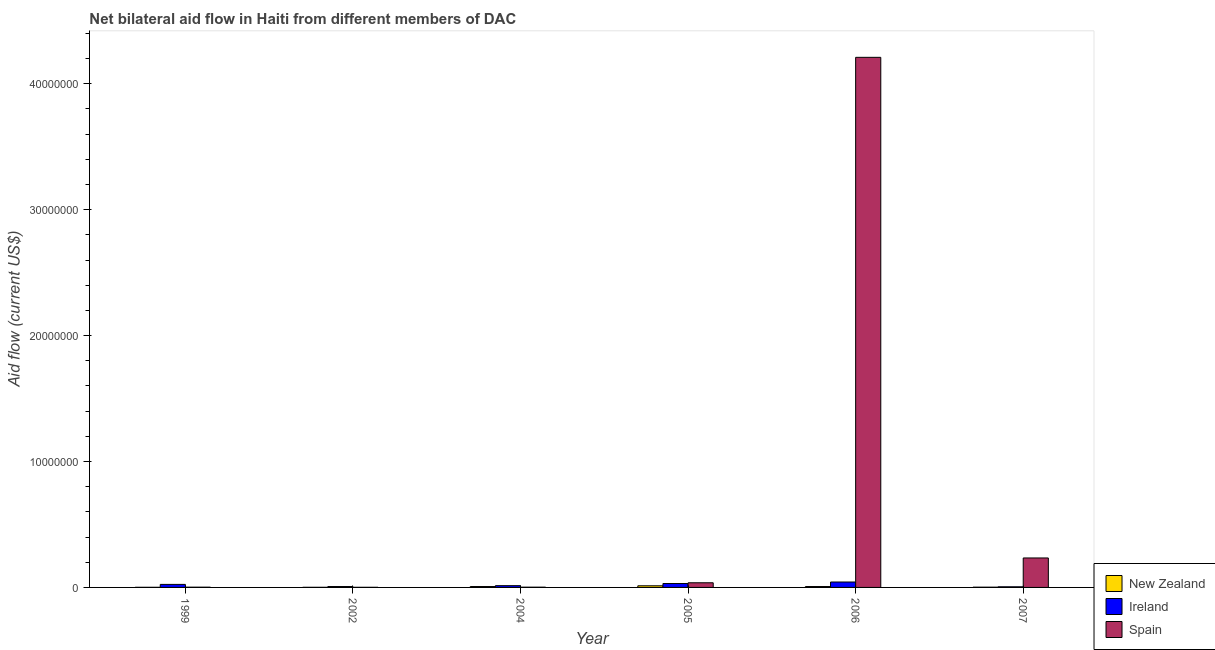How many groups of bars are there?
Provide a short and direct response. 6. In how many cases, is the number of bars for a given year not equal to the number of legend labels?
Provide a succinct answer. 0. What is the amount of aid provided by ireland in 2004?
Your answer should be compact. 1.40e+05. Across all years, what is the maximum amount of aid provided by spain?
Make the answer very short. 4.21e+07. Across all years, what is the minimum amount of aid provided by new zealand?
Provide a short and direct response. 10000. In which year was the amount of aid provided by spain minimum?
Your answer should be very brief. 2002. What is the total amount of aid provided by new zealand in the graph?
Keep it short and to the point. 3.10e+05. What is the difference between the amount of aid provided by new zealand in 2004 and that in 2007?
Your answer should be very brief. 5.00e+04. What is the difference between the amount of aid provided by new zealand in 2007 and the amount of aid provided by ireland in 2002?
Give a very brief answer. 10000. What is the average amount of aid provided by ireland per year?
Make the answer very short. 2.07e+05. In the year 2002, what is the difference between the amount of aid provided by spain and amount of aid provided by new zealand?
Keep it short and to the point. 0. In how many years, is the amount of aid provided by spain greater than 30000000 US$?
Offer a very short reply. 1. What is the ratio of the amount of aid provided by new zealand in 1999 to that in 2007?
Offer a terse response. 0.5. Is the amount of aid provided by ireland in 2002 less than that in 2006?
Ensure brevity in your answer.  Yes. Is the difference between the amount of aid provided by new zealand in 2004 and 2007 greater than the difference between the amount of aid provided by ireland in 2004 and 2007?
Keep it short and to the point. No. What is the difference between the highest and the lowest amount of aid provided by spain?
Your answer should be very brief. 4.21e+07. In how many years, is the amount of aid provided by spain greater than the average amount of aid provided by spain taken over all years?
Give a very brief answer. 1. Is the sum of the amount of aid provided by ireland in 1999 and 2004 greater than the maximum amount of aid provided by spain across all years?
Keep it short and to the point. No. What does the 2nd bar from the left in 2005 represents?
Make the answer very short. Ireland. What does the 2nd bar from the right in 2004 represents?
Your answer should be compact. Ireland. Is it the case that in every year, the sum of the amount of aid provided by new zealand and amount of aid provided by ireland is greater than the amount of aid provided by spain?
Offer a terse response. No. How many bars are there?
Make the answer very short. 18. Are all the bars in the graph horizontal?
Offer a terse response. No. How many years are there in the graph?
Your answer should be compact. 6. What is the difference between two consecutive major ticks on the Y-axis?
Ensure brevity in your answer.  1.00e+07. Does the graph contain any zero values?
Keep it short and to the point. No. Does the graph contain grids?
Your answer should be compact. No. How are the legend labels stacked?
Your answer should be compact. Vertical. What is the title of the graph?
Ensure brevity in your answer.  Net bilateral aid flow in Haiti from different members of DAC. What is the label or title of the Y-axis?
Provide a short and direct response. Aid flow (current US$). What is the Aid flow (current US$) of New Zealand in 1999?
Make the answer very short. 10000. What is the Aid flow (current US$) of Spain in 1999?
Your response must be concise. 2.00e+04. What is the Aid flow (current US$) of New Zealand in 2002?
Keep it short and to the point. 10000. What is the Aid flow (current US$) in Ireland in 2002?
Offer a very short reply. 7.00e+04. What is the Aid flow (current US$) in Spain in 2002?
Give a very brief answer. 10000. What is the Aid flow (current US$) of New Zealand in 2004?
Offer a terse response. 7.00e+04. What is the Aid flow (current US$) in Ireland in 2004?
Ensure brevity in your answer.  1.40e+05. What is the Aid flow (current US$) of Spain in 2004?
Your answer should be compact. 2.00e+04. What is the Aid flow (current US$) of Spain in 2005?
Keep it short and to the point. 3.70e+05. What is the Aid flow (current US$) in New Zealand in 2006?
Ensure brevity in your answer.  7.00e+04. What is the Aid flow (current US$) of Ireland in 2006?
Your answer should be compact. 4.30e+05. What is the Aid flow (current US$) of Spain in 2006?
Provide a succinct answer. 4.21e+07. What is the Aid flow (current US$) in Ireland in 2007?
Give a very brief answer. 5.00e+04. What is the Aid flow (current US$) of Spain in 2007?
Keep it short and to the point. 2.34e+06. Across all years, what is the maximum Aid flow (current US$) in Spain?
Provide a succinct answer. 4.21e+07. Across all years, what is the minimum Aid flow (current US$) in Ireland?
Keep it short and to the point. 5.00e+04. What is the total Aid flow (current US$) of Ireland in the graph?
Ensure brevity in your answer.  1.24e+06. What is the total Aid flow (current US$) of Spain in the graph?
Offer a very short reply. 4.49e+07. What is the difference between the Aid flow (current US$) of Ireland in 1999 and that in 2002?
Provide a short and direct response. 1.70e+05. What is the difference between the Aid flow (current US$) of Ireland in 1999 and that in 2004?
Your response must be concise. 1.00e+05. What is the difference between the Aid flow (current US$) of Spain in 1999 and that in 2004?
Your answer should be very brief. 0. What is the difference between the Aid flow (current US$) of Spain in 1999 and that in 2005?
Ensure brevity in your answer.  -3.50e+05. What is the difference between the Aid flow (current US$) in Spain in 1999 and that in 2006?
Your answer should be compact. -4.21e+07. What is the difference between the Aid flow (current US$) of New Zealand in 1999 and that in 2007?
Keep it short and to the point. -10000. What is the difference between the Aid flow (current US$) in Spain in 1999 and that in 2007?
Ensure brevity in your answer.  -2.32e+06. What is the difference between the Aid flow (current US$) of New Zealand in 2002 and that in 2004?
Keep it short and to the point. -6.00e+04. What is the difference between the Aid flow (current US$) in Ireland in 2002 and that in 2004?
Offer a terse response. -7.00e+04. What is the difference between the Aid flow (current US$) in Spain in 2002 and that in 2004?
Offer a very short reply. -10000. What is the difference between the Aid flow (current US$) in New Zealand in 2002 and that in 2005?
Your answer should be very brief. -1.20e+05. What is the difference between the Aid flow (current US$) of Ireland in 2002 and that in 2005?
Offer a terse response. -2.40e+05. What is the difference between the Aid flow (current US$) in Spain in 2002 and that in 2005?
Give a very brief answer. -3.60e+05. What is the difference between the Aid flow (current US$) of New Zealand in 2002 and that in 2006?
Your answer should be very brief. -6.00e+04. What is the difference between the Aid flow (current US$) of Ireland in 2002 and that in 2006?
Offer a terse response. -3.60e+05. What is the difference between the Aid flow (current US$) in Spain in 2002 and that in 2006?
Keep it short and to the point. -4.21e+07. What is the difference between the Aid flow (current US$) of New Zealand in 2002 and that in 2007?
Make the answer very short. -10000. What is the difference between the Aid flow (current US$) of Ireland in 2002 and that in 2007?
Your answer should be very brief. 2.00e+04. What is the difference between the Aid flow (current US$) of Spain in 2002 and that in 2007?
Your answer should be compact. -2.33e+06. What is the difference between the Aid flow (current US$) in New Zealand in 2004 and that in 2005?
Your response must be concise. -6.00e+04. What is the difference between the Aid flow (current US$) of Spain in 2004 and that in 2005?
Ensure brevity in your answer.  -3.50e+05. What is the difference between the Aid flow (current US$) in Ireland in 2004 and that in 2006?
Provide a short and direct response. -2.90e+05. What is the difference between the Aid flow (current US$) of Spain in 2004 and that in 2006?
Make the answer very short. -4.21e+07. What is the difference between the Aid flow (current US$) in New Zealand in 2004 and that in 2007?
Offer a very short reply. 5.00e+04. What is the difference between the Aid flow (current US$) of Spain in 2004 and that in 2007?
Make the answer very short. -2.32e+06. What is the difference between the Aid flow (current US$) of New Zealand in 2005 and that in 2006?
Your answer should be compact. 6.00e+04. What is the difference between the Aid flow (current US$) of Ireland in 2005 and that in 2006?
Provide a short and direct response. -1.20e+05. What is the difference between the Aid flow (current US$) in Spain in 2005 and that in 2006?
Your response must be concise. -4.17e+07. What is the difference between the Aid flow (current US$) of New Zealand in 2005 and that in 2007?
Provide a short and direct response. 1.10e+05. What is the difference between the Aid flow (current US$) of Ireland in 2005 and that in 2007?
Ensure brevity in your answer.  2.60e+05. What is the difference between the Aid flow (current US$) in Spain in 2005 and that in 2007?
Provide a short and direct response. -1.97e+06. What is the difference between the Aid flow (current US$) of Spain in 2006 and that in 2007?
Offer a terse response. 3.98e+07. What is the difference between the Aid flow (current US$) of Ireland in 1999 and the Aid flow (current US$) of Spain in 2002?
Your answer should be compact. 2.30e+05. What is the difference between the Aid flow (current US$) of New Zealand in 1999 and the Aid flow (current US$) of Spain in 2005?
Provide a short and direct response. -3.60e+05. What is the difference between the Aid flow (current US$) of New Zealand in 1999 and the Aid flow (current US$) of Ireland in 2006?
Your answer should be very brief. -4.20e+05. What is the difference between the Aid flow (current US$) of New Zealand in 1999 and the Aid flow (current US$) of Spain in 2006?
Your response must be concise. -4.21e+07. What is the difference between the Aid flow (current US$) of Ireland in 1999 and the Aid flow (current US$) of Spain in 2006?
Your answer should be very brief. -4.19e+07. What is the difference between the Aid flow (current US$) of New Zealand in 1999 and the Aid flow (current US$) of Spain in 2007?
Your answer should be compact. -2.33e+06. What is the difference between the Aid flow (current US$) in Ireland in 1999 and the Aid flow (current US$) in Spain in 2007?
Give a very brief answer. -2.10e+06. What is the difference between the Aid flow (current US$) of New Zealand in 2002 and the Aid flow (current US$) of Ireland in 2004?
Offer a very short reply. -1.30e+05. What is the difference between the Aid flow (current US$) of New Zealand in 2002 and the Aid flow (current US$) of Ireland in 2005?
Your answer should be compact. -3.00e+05. What is the difference between the Aid flow (current US$) in New Zealand in 2002 and the Aid flow (current US$) in Spain in 2005?
Provide a short and direct response. -3.60e+05. What is the difference between the Aid flow (current US$) in New Zealand in 2002 and the Aid flow (current US$) in Ireland in 2006?
Provide a short and direct response. -4.20e+05. What is the difference between the Aid flow (current US$) of New Zealand in 2002 and the Aid flow (current US$) of Spain in 2006?
Offer a very short reply. -4.21e+07. What is the difference between the Aid flow (current US$) in Ireland in 2002 and the Aid flow (current US$) in Spain in 2006?
Provide a short and direct response. -4.20e+07. What is the difference between the Aid flow (current US$) in New Zealand in 2002 and the Aid flow (current US$) in Ireland in 2007?
Your response must be concise. -4.00e+04. What is the difference between the Aid flow (current US$) in New Zealand in 2002 and the Aid flow (current US$) in Spain in 2007?
Offer a very short reply. -2.33e+06. What is the difference between the Aid flow (current US$) in Ireland in 2002 and the Aid flow (current US$) in Spain in 2007?
Provide a short and direct response. -2.27e+06. What is the difference between the Aid flow (current US$) in Ireland in 2004 and the Aid flow (current US$) in Spain in 2005?
Give a very brief answer. -2.30e+05. What is the difference between the Aid flow (current US$) of New Zealand in 2004 and the Aid flow (current US$) of Ireland in 2006?
Provide a succinct answer. -3.60e+05. What is the difference between the Aid flow (current US$) of New Zealand in 2004 and the Aid flow (current US$) of Spain in 2006?
Offer a very short reply. -4.20e+07. What is the difference between the Aid flow (current US$) in Ireland in 2004 and the Aid flow (current US$) in Spain in 2006?
Offer a terse response. -4.20e+07. What is the difference between the Aid flow (current US$) in New Zealand in 2004 and the Aid flow (current US$) in Spain in 2007?
Ensure brevity in your answer.  -2.27e+06. What is the difference between the Aid flow (current US$) in Ireland in 2004 and the Aid flow (current US$) in Spain in 2007?
Offer a terse response. -2.20e+06. What is the difference between the Aid flow (current US$) in New Zealand in 2005 and the Aid flow (current US$) in Spain in 2006?
Provide a succinct answer. -4.20e+07. What is the difference between the Aid flow (current US$) in Ireland in 2005 and the Aid flow (current US$) in Spain in 2006?
Provide a short and direct response. -4.18e+07. What is the difference between the Aid flow (current US$) of New Zealand in 2005 and the Aid flow (current US$) of Spain in 2007?
Offer a very short reply. -2.21e+06. What is the difference between the Aid flow (current US$) of Ireland in 2005 and the Aid flow (current US$) of Spain in 2007?
Ensure brevity in your answer.  -2.03e+06. What is the difference between the Aid flow (current US$) of New Zealand in 2006 and the Aid flow (current US$) of Spain in 2007?
Make the answer very short. -2.27e+06. What is the difference between the Aid flow (current US$) of Ireland in 2006 and the Aid flow (current US$) of Spain in 2007?
Keep it short and to the point. -1.91e+06. What is the average Aid flow (current US$) of New Zealand per year?
Give a very brief answer. 5.17e+04. What is the average Aid flow (current US$) of Ireland per year?
Ensure brevity in your answer.  2.07e+05. What is the average Aid flow (current US$) in Spain per year?
Make the answer very short. 7.48e+06. In the year 1999, what is the difference between the Aid flow (current US$) of New Zealand and Aid flow (current US$) of Spain?
Keep it short and to the point. -10000. In the year 2004, what is the difference between the Aid flow (current US$) in New Zealand and Aid flow (current US$) in Spain?
Keep it short and to the point. 5.00e+04. In the year 2005, what is the difference between the Aid flow (current US$) of New Zealand and Aid flow (current US$) of Spain?
Ensure brevity in your answer.  -2.40e+05. In the year 2006, what is the difference between the Aid flow (current US$) of New Zealand and Aid flow (current US$) of Ireland?
Your answer should be very brief. -3.60e+05. In the year 2006, what is the difference between the Aid flow (current US$) of New Zealand and Aid flow (current US$) of Spain?
Offer a terse response. -4.20e+07. In the year 2006, what is the difference between the Aid flow (current US$) in Ireland and Aid flow (current US$) in Spain?
Keep it short and to the point. -4.17e+07. In the year 2007, what is the difference between the Aid flow (current US$) of New Zealand and Aid flow (current US$) of Ireland?
Give a very brief answer. -3.00e+04. In the year 2007, what is the difference between the Aid flow (current US$) in New Zealand and Aid flow (current US$) in Spain?
Provide a short and direct response. -2.32e+06. In the year 2007, what is the difference between the Aid flow (current US$) of Ireland and Aid flow (current US$) of Spain?
Your answer should be compact. -2.29e+06. What is the ratio of the Aid flow (current US$) in Ireland in 1999 to that in 2002?
Provide a succinct answer. 3.43. What is the ratio of the Aid flow (current US$) in Spain in 1999 to that in 2002?
Ensure brevity in your answer.  2. What is the ratio of the Aid flow (current US$) of New Zealand in 1999 to that in 2004?
Your response must be concise. 0.14. What is the ratio of the Aid flow (current US$) of Ireland in 1999 to that in 2004?
Your response must be concise. 1.71. What is the ratio of the Aid flow (current US$) of Spain in 1999 to that in 2004?
Provide a succinct answer. 1. What is the ratio of the Aid flow (current US$) in New Zealand in 1999 to that in 2005?
Ensure brevity in your answer.  0.08. What is the ratio of the Aid flow (current US$) of Ireland in 1999 to that in 2005?
Ensure brevity in your answer.  0.77. What is the ratio of the Aid flow (current US$) in Spain in 1999 to that in 2005?
Provide a short and direct response. 0.05. What is the ratio of the Aid flow (current US$) of New Zealand in 1999 to that in 2006?
Provide a succinct answer. 0.14. What is the ratio of the Aid flow (current US$) in Ireland in 1999 to that in 2006?
Your answer should be very brief. 0.56. What is the ratio of the Aid flow (current US$) of Spain in 1999 to that in 2007?
Offer a very short reply. 0.01. What is the ratio of the Aid flow (current US$) in New Zealand in 2002 to that in 2004?
Make the answer very short. 0.14. What is the ratio of the Aid flow (current US$) in New Zealand in 2002 to that in 2005?
Give a very brief answer. 0.08. What is the ratio of the Aid flow (current US$) of Ireland in 2002 to that in 2005?
Your response must be concise. 0.23. What is the ratio of the Aid flow (current US$) in Spain in 2002 to that in 2005?
Your response must be concise. 0.03. What is the ratio of the Aid flow (current US$) in New Zealand in 2002 to that in 2006?
Your answer should be compact. 0.14. What is the ratio of the Aid flow (current US$) of Ireland in 2002 to that in 2006?
Give a very brief answer. 0.16. What is the ratio of the Aid flow (current US$) of Spain in 2002 to that in 2006?
Provide a succinct answer. 0. What is the ratio of the Aid flow (current US$) of New Zealand in 2002 to that in 2007?
Your response must be concise. 0.5. What is the ratio of the Aid flow (current US$) of Ireland in 2002 to that in 2007?
Provide a succinct answer. 1.4. What is the ratio of the Aid flow (current US$) of Spain in 2002 to that in 2007?
Keep it short and to the point. 0. What is the ratio of the Aid flow (current US$) of New Zealand in 2004 to that in 2005?
Provide a succinct answer. 0.54. What is the ratio of the Aid flow (current US$) of Ireland in 2004 to that in 2005?
Your answer should be very brief. 0.45. What is the ratio of the Aid flow (current US$) of Spain in 2004 to that in 2005?
Provide a short and direct response. 0.05. What is the ratio of the Aid flow (current US$) in Ireland in 2004 to that in 2006?
Provide a succinct answer. 0.33. What is the ratio of the Aid flow (current US$) of Spain in 2004 to that in 2006?
Provide a short and direct response. 0. What is the ratio of the Aid flow (current US$) in New Zealand in 2004 to that in 2007?
Ensure brevity in your answer.  3.5. What is the ratio of the Aid flow (current US$) in Spain in 2004 to that in 2007?
Offer a very short reply. 0.01. What is the ratio of the Aid flow (current US$) of New Zealand in 2005 to that in 2006?
Ensure brevity in your answer.  1.86. What is the ratio of the Aid flow (current US$) in Ireland in 2005 to that in 2006?
Provide a succinct answer. 0.72. What is the ratio of the Aid flow (current US$) in Spain in 2005 to that in 2006?
Offer a terse response. 0.01. What is the ratio of the Aid flow (current US$) in Ireland in 2005 to that in 2007?
Offer a terse response. 6.2. What is the ratio of the Aid flow (current US$) of Spain in 2005 to that in 2007?
Your response must be concise. 0.16. What is the ratio of the Aid flow (current US$) of New Zealand in 2006 to that in 2007?
Your response must be concise. 3.5. What is the ratio of the Aid flow (current US$) in Ireland in 2006 to that in 2007?
Offer a terse response. 8.6. What is the ratio of the Aid flow (current US$) of Spain in 2006 to that in 2007?
Ensure brevity in your answer.  17.99. What is the difference between the highest and the second highest Aid flow (current US$) of Spain?
Ensure brevity in your answer.  3.98e+07. What is the difference between the highest and the lowest Aid flow (current US$) of Spain?
Your answer should be very brief. 4.21e+07. 